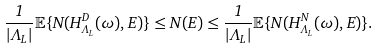<formula> <loc_0><loc_0><loc_500><loc_500>\frac { 1 } { | \Lambda _ { L } | } \mathbb { E } \{ N ( H _ { \Lambda _ { L } } ^ { D } ( \omega ) , E ) \} \leq N ( E ) \leq \frac { 1 } { | \Lambda _ { L } | } \mathbb { E } \{ N ( H _ { \Lambda _ { L } } ^ { N } ( \omega ) , E ) \} .</formula> 